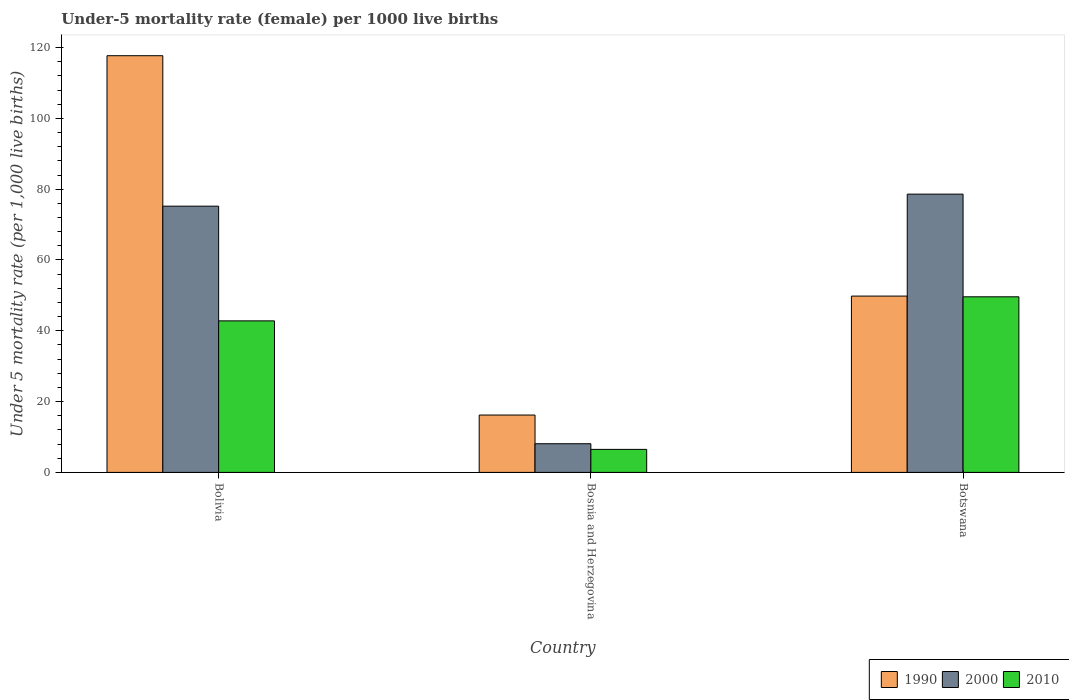How many groups of bars are there?
Provide a short and direct response. 3. What is the label of the 3rd group of bars from the left?
Your answer should be very brief. Botswana. Across all countries, what is the maximum under-five mortality rate in 2000?
Ensure brevity in your answer.  78.6. Across all countries, what is the minimum under-five mortality rate in 1990?
Make the answer very short. 16.2. In which country was the under-five mortality rate in 2000 minimum?
Provide a short and direct response. Bosnia and Herzegovina. What is the total under-five mortality rate in 2000 in the graph?
Ensure brevity in your answer.  161.9. What is the difference between the under-five mortality rate in 1990 in Bolivia and that in Bosnia and Herzegovina?
Give a very brief answer. 101.5. What is the difference between the under-five mortality rate in 1990 in Bosnia and Herzegovina and the under-five mortality rate in 2000 in Botswana?
Offer a very short reply. -62.4. What is the average under-five mortality rate in 1990 per country?
Offer a terse response. 61.23. What is the difference between the under-five mortality rate of/in 2010 and under-five mortality rate of/in 1990 in Bosnia and Herzegovina?
Your answer should be very brief. -9.7. In how many countries, is the under-five mortality rate in 1990 greater than 52?
Your answer should be very brief. 1. What is the ratio of the under-five mortality rate in 2010 in Bolivia to that in Botswana?
Provide a succinct answer. 0.86. Is the under-five mortality rate in 1990 in Bolivia less than that in Botswana?
Provide a succinct answer. No. What is the difference between the highest and the second highest under-five mortality rate in 1990?
Your response must be concise. -33.6. What is the difference between the highest and the lowest under-five mortality rate in 2010?
Make the answer very short. 43.1. In how many countries, is the under-five mortality rate in 1990 greater than the average under-five mortality rate in 1990 taken over all countries?
Keep it short and to the point. 1. Is the sum of the under-five mortality rate in 1990 in Bosnia and Herzegovina and Botswana greater than the maximum under-five mortality rate in 2000 across all countries?
Ensure brevity in your answer.  No. What does the 2nd bar from the left in Bolivia represents?
Give a very brief answer. 2000. How many bars are there?
Offer a very short reply. 9. How many countries are there in the graph?
Offer a terse response. 3. Does the graph contain grids?
Your answer should be compact. No. How many legend labels are there?
Offer a terse response. 3. How are the legend labels stacked?
Your answer should be very brief. Horizontal. What is the title of the graph?
Provide a succinct answer. Under-5 mortality rate (female) per 1000 live births. What is the label or title of the X-axis?
Offer a terse response. Country. What is the label or title of the Y-axis?
Provide a succinct answer. Under 5 mortality rate (per 1,0 live births). What is the Under 5 mortality rate (per 1,000 live births) in 1990 in Bolivia?
Your answer should be compact. 117.7. What is the Under 5 mortality rate (per 1,000 live births) of 2000 in Bolivia?
Offer a very short reply. 75.2. What is the Under 5 mortality rate (per 1,000 live births) in 2010 in Bolivia?
Provide a succinct answer. 42.8. What is the Under 5 mortality rate (per 1,000 live births) in 1990 in Botswana?
Make the answer very short. 49.8. What is the Under 5 mortality rate (per 1,000 live births) in 2000 in Botswana?
Your answer should be compact. 78.6. What is the Under 5 mortality rate (per 1,000 live births) of 2010 in Botswana?
Provide a short and direct response. 49.6. Across all countries, what is the maximum Under 5 mortality rate (per 1,000 live births) in 1990?
Ensure brevity in your answer.  117.7. Across all countries, what is the maximum Under 5 mortality rate (per 1,000 live births) of 2000?
Offer a very short reply. 78.6. Across all countries, what is the maximum Under 5 mortality rate (per 1,000 live births) in 2010?
Your answer should be compact. 49.6. What is the total Under 5 mortality rate (per 1,000 live births) in 1990 in the graph?
Your response must be concise. 183.7. What is the total Under 5 mortality rate (per 1,000 live births) in 2000 in the graph?
Your answer should be compact. 161.9. What is the total Under 5 mortality rate (per 1,000 live births) in 2010 in the graph?
Your response must be concise. 98.9. What is the difference between the Under 5 mortality rate (per 1,000 live births) of 1990 in Bolivia and that in Bosnia and Herzegovina?
Your response must be concise. 101.5. What is the difference between the Under 5 mortality rate (per 1,000 live births) in 2000 in Bolivia and that in Bosnia and Herzegovina?
Offer a very short reply. 67.1. What is the difference between the Under 5 mortality rate (per 1,000 live births) of 2010 in Bolivia and that in Bosnia and Herzegovina?
Your answer should be compact. 36.3. What is the difference between the Under 5 mortality rate (per 1,000 live births) in 1990 in Bolivia and that in Botswana?
Provide a short and direct response. 67.9. What is the difference between the Under 5 mortality rate (per 1,000 live births) of 2000 in Bolivia and that in Botswana?
Offer a very short reply. -3.4. What is the difference between the Under 5 mortality rate (per 1,000 live births) of 1990 in Bosnia and Herzegovina and that in Botswana?
Provide a succinct answer. -33.6. What is the difference between the Under 5 mortality rate (per 1,000 live births) of 2000 in Bosnia and Herzegovina and that in Botswana?
Your answer should be very brief. -70.5. What is the difference between the Under 5 mortality rate (per 1,000 live births) in 2010 in Bosnia and Herzegovina and that in Botswana?
Your response must be concise. -43.1. What is the difference between the Under 5 mortality rate (per 1,000 live births) of 1990 in Bolivia and the Under 5 mortality rate (per 1,000 live births) of 2000 in Bosnia and Herzegovina?
Your answer should be very brief. 109.6. What is the difference between the Under 5 mortality rate (per 1,000 live births) of 1990 in Bolivia and the Under 5 mortality rate (per 1,000 live births) of 2010 in Bosnia and Herzegovina?
Your response must be concise. 111.2. What is the difference between the Under 5 mortality rate (per 1,000 live births) of 2000 in Bolivia and the Under 5 mortality rate (per 1,000 live births) of 2010 in Bosnia and Herzegovina?
Provide a short and direct response. 68.7. What is the difference between the Under 5 mortality rate (per 1,000 live births) of 1990 in Bolivia and the Under 5 mortality rate (per 1,000 live births) of 2000 in Botswana?
Offer a very short reply. 39.1. What is the difference between the Under 5 mortality rate (per 1,000 live births) in 1990 in Bolivia and the Under 5 mortality rate (per 1,000 live births) in 2010 in Botswana?
Your answer should be compact. 68.1. What is the difference between the Under 5 mortality rate (per 1,000 live births) in 2000 in Bolivia and the Under 5 mortality rate (per 1,000 live births) in 2010 in Botswana?
Provide a short and direct response. 25.6. What is the difference between the Under 5 mortality rate (per 1,000 live births) in 1990 in Bosnia and Herzegovina and the Under 5 mortality rate (per 1,000 live births) in 2000 in Botswana?
Make the answer very short. -62.4. What is the difference between the Under 5 mortality rate (per 1,000 live births) of 1990 in Bosnia and Herzegovina and the Under 5 mortality rate (per 1,000 live births) of 2010 in Botswana?
Your answer should be compact. -33.4. What is the difference between the Under 5 mortality rate (per 1,000 live births) in 2000 in Bosnia and Herzegovina and the Under 5 mortality rate (per 1,000 live births) in 2010 in Botswana?
Your response must be concise. -41.5. What is the average Under 5 mortality rate (per 1,000 live births) of 1990 per country?
Your response must be concise. 61.23. What is the average Under 5 mortality rate (per 1,000 live births) of 2000 per country?
Give a very brief answer. 53.97. What is the average Under 5 mortality rate (per 1,000 live births) of 2010 per country?
Your response must be concise. 32.97. What is the difference between the Under 5 mortality rate (per 1,000 live births) of 1990 and Under 5 mortality rate (per 1,000 live births) of 2000 in Bolivia?
Make the answer very short. 42.5. What is the difference between the Under 5 mortality rate (per 1,000 live births) of 1990 and Under 5 mortality rate (per 1,000 live births) of 2010 in Bolivia?
Make the answer very short. 74.9. What is the difference between the Under 5 mortality rate (per 1,000 live births) of 2000 and Under 5 mortality rate (per 1,000 live births) of 2010 in Bolivia?
Keep it short and to the point. 32.4. What is the difference between the Under 5 mortality rate (per 1,000 live births) of 1990 and Under 5 mortality rate (per 1,000 live births) of 2000 in Bosnia and Herzegovina?
Keep it short and to the point. 8.1. What is the difference between the Under 5 mortality rate (per 1,000 live births) in 1990 and Under 5 mortality rate (per 1,000 live births) in 2010 in Bosnia and Herzegovina?
Offer a very short reply. 9.7. What is the difference between the Under 5 mortality rate (per 1,000 live births) in 1990 and Under 5 mortality rate (per 1,000 live births) in 2000 in Botswana?
Your answer should be very brief. -28.8. What is the ratio of the Under 5 mortality rate (per 1,000 live births) in 1990 in Bolivia to that in Bosnia and Herzegovina?
Make the answer very short. 7.27. What is the ratio of the Under 5 mortality rate (per 1,000 live births) in 2000 in Bolivia to that in Bosnia and Herzegovina?
Provide a short and direct response. 9.28. What is the ratio of the Under 5 mortality rate (per 1,000 live births) in 2010 in Bolivia to that in Bosnia and Herzegovina?
Ensure brevity in your answer.  6.58. What is the ratio of the Under 5 mortality rate (per 1,000 live births) of 1990 in Bolivia to that in Botswana?
Your response must be concise. 2.36. What is the ratio of the Under 5 mortality rate (per 1,000 live births) in 2000 in Bolivia to that in Botswana?
Give a very brief answer. 0.96. What is the ratio of the Under 5 mortality rate (per 1,000 live births) in 2010 in Bolivia to that in Botswana?
Provide a succinct answer. 0.86. What is the ratio of the Under 5 mortality rate (per 1,000 live births) of 1990 in Bosnia and Herzegovina to that in Botswana?
Provide a short and direct response. 0.33. What is the ratio of the Under 5 mortality rate (per 1,000 live births) in 2000 in Bosnia and Herzegovina to that in Botswana?
Provide a short and direct response. 0.1. What is the ratio of the Under 5 mortality rate (per 1,000 live births) in 2010 in Bosnia and Herzegovina to that in Botswana?
Give a very brief answer. 0.13. What is the difference between the highest and the second highest Under 5 mortality rate (per 1,000 live births) of 1990?
Your answer should be very brief. 67.9. What is the difference between the highest and the lowest Under 5 mortality rate (per 1,000 live births) of 1990?
Make the answer very short. 101.5. What is the difference between the highest and the lowest Under 5 mortality rate (per 1,000 live births) of 2000?
Offer a terse response. 70.5. What is the difference between the highest and the lowest Under 5 mortality rate (per 1,000 live births) in 2010?
Your answer should be compact. 43.1. 